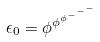Convert formula to latex. <formula><loc_0><loc_0><loc_500><loc_500>\epsilon _ { 0 } = \phi ^ { \phi ^ { \phi ^ { - ^ { - ^ { - } } } } }</formula> 